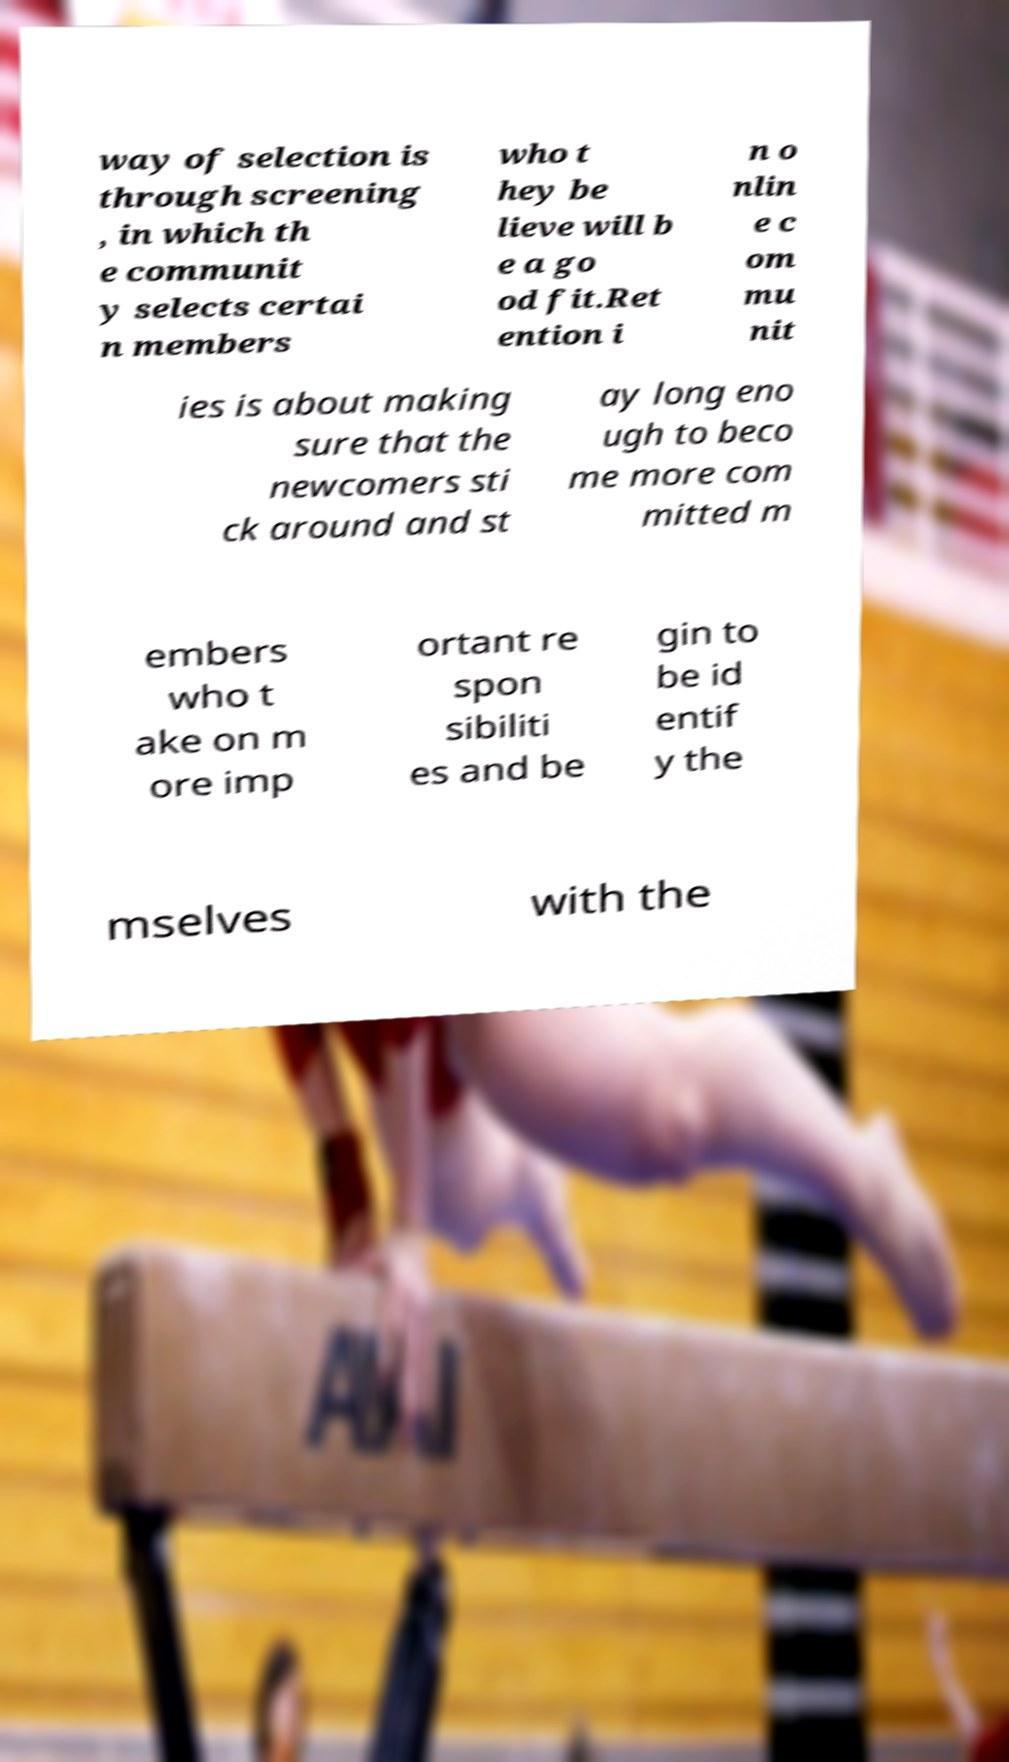Please read and relay the text visible in this image. What does it say? way of selection is through screening , in which th e communit y selects certai n members who t hey be lieve will b e a go od fit.Ret ention i n o nlin e c om mu nit ies is about making sure that the newcomers sti ck around and st ay long eno ugh to beco me more com mitted m embers who t ake on m ore imp ortant re spon sibiliti es and be gin to be id entif y the mselves with the 